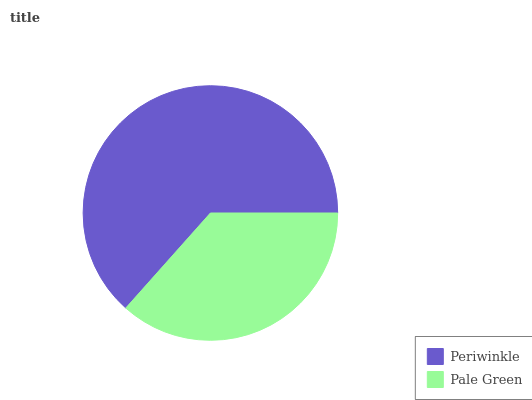Is Pale Green the minimum?
Answer yes or no. Yes. Is Periwinkle the maximum?
Answer yes or no. Yes. Is Pale Green the maximum?
Answer yes or no. No. Is Periwinkle greater than Pale Green?
Answer yes or no. Yes. Is Pale Green less than Periwinkle?
Answer yes or no. Yes. Is Pale Green greater than Periwinkle?
Answer yes or no. No. Is Periwinkle less than Pale Green?
Answer yes or no. No. Is Periwinkle the high median?
Answer yes or no. Yes. Is Pale Green the low median?
Answer yes or no. Yes. Is Pale Green the high median?
Answer yes or no. No. Is Periwinkle the low median?
Answer yes or no. No. 